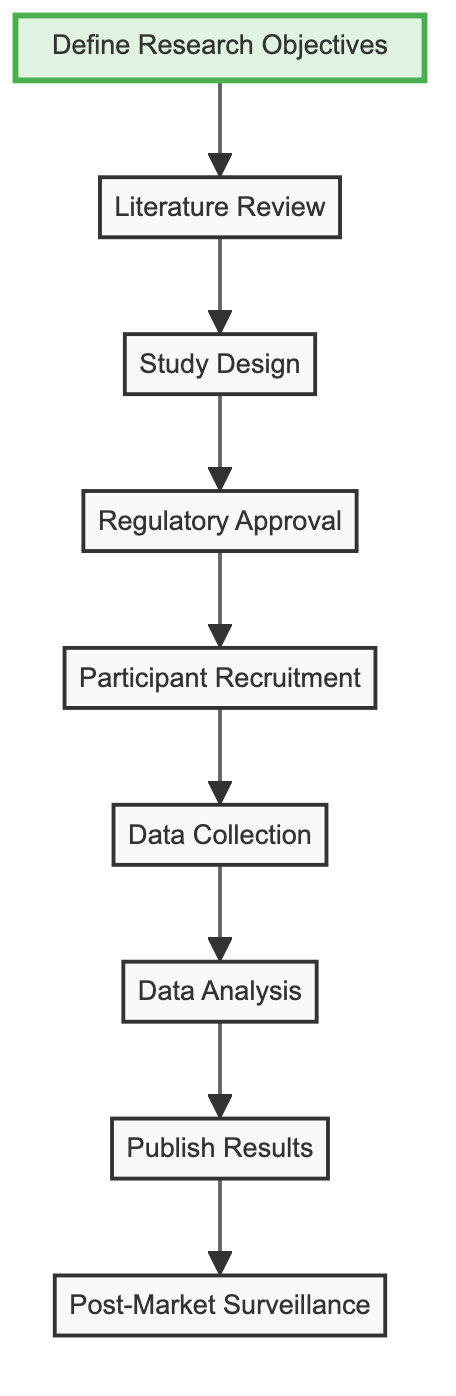What's the first step in the workflow? The diagram indicates that the first step is "Define Research Objectives." It is the starting point of the flow chart and connects to the second step.
Answer: Define Research Objectives How many steps are there in total? The diagram shows a total of nine steps, as there are nine distinct nodes representing each step in the clinical trial workflow.
Answer: 9 Which step comes after "Regulatory Approval"? According to the flow chart, the step that follows "Regulatory Approval" is "Participant Recruitment," indicating the next action after regulatory processes are completed.
Answer: Participant Recruitment What is the last step in the workflow? The last step in the flow chart is "Post-Market Surveillance," which concludes the sequence of actions following the study and publication of results.
Answer: Post-Market Surveillance Which two steps are directly connected to "Data Collection"? The diagram shows that "Data Collection" is directly connected to "Participant Recruitment" (before it) and "Data Analysis" (after it), indicating its role in the workflow.
Answer: Participant Recruitment and Data Analysis What must be completed before "Data Analysis" can occur? Before "Data Analysis" can take place, "Data Collection" must be completed, as indicated in the flow of the diagram where these two steps are sequentially connected.
Answer: Data Collection What does step "Literature Review" focus on? The "Literature Review" step focuses on conducting a comprehensive review of existing studies on both the brand-name and generic versions, as described in the flow chart.
Answer: Existing studies Name one regulatory body mentioned that approvals should be submitted to. The flow chart specifies that trial protocols should be submitted to regulatory bodies such as the FDA or EMA, focusing on their role in the approval process.
Answer: FDA Which step follows "Publish Results"? Following "Publish Results," the next step in the diagram is "Post-Market Surveillance," which involves monitoring the drug after its release into the market.
Answer: Post-Market Surveillance What is the main goal of "Define Research Objectives"? The main goal of "Define Research Objectives" is to establish goals for evaluating both the effectiveness and safety of the generic drug, as outlined in the rise of steps in the diagram.
Answer: Goals for evaluating effectiveness and safety 